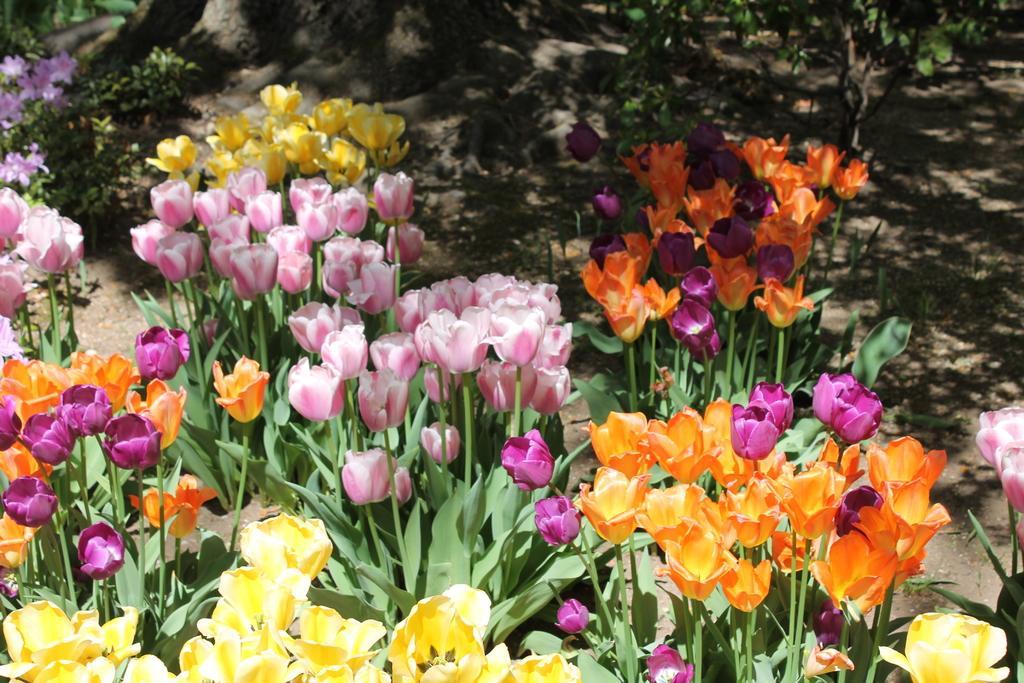How would you summarize this image in a sentence or two? In the picture i can see some flowers which are in different colors like yellow, pink,red and in the background of the picture there are some plants. 